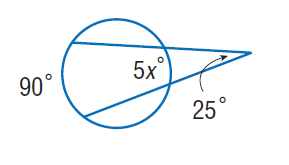Question: Find x. Assume that any segment that appears to be tangent is tangent.
Choices:
A. 8
B. 25
C. 40
D. 90
Answer with the letter. Answer: A 